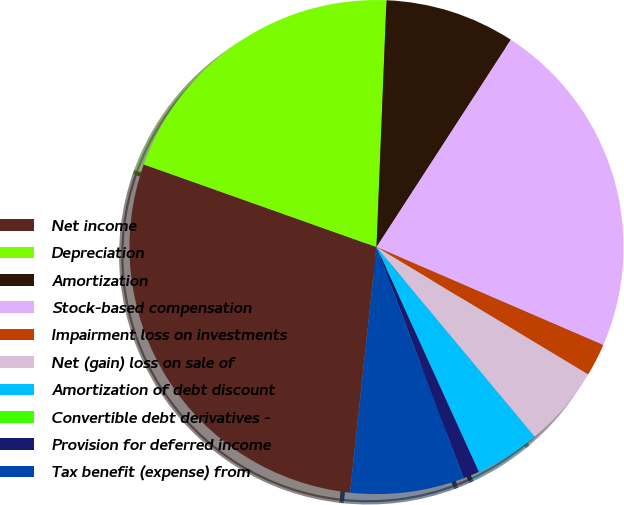<chart> <loc_0><loc_0><loc_500><loc_500><pie_chart><fcel>Net income<fcel>Depreciation<fcel>Amortization<fcel>Stock-based compensation<fcel>Impairment loss on investments<fcel>Net (gain) loss on sale of<fcel>Amortization of debt discount<fcel>Convertible debt derivatives -<fcel>Provision for deferred income<fcel>Tax benefit (expense) from<nl><fcel>28.72%<fcel>20.21%<fcel>8.51%<fcel>22.34%<fcel>2.13%<fcel>5.32%<fcel>4.26%<fcel>0.0%<fcel>1.06%<fcel>7.45%<nl></chart> 